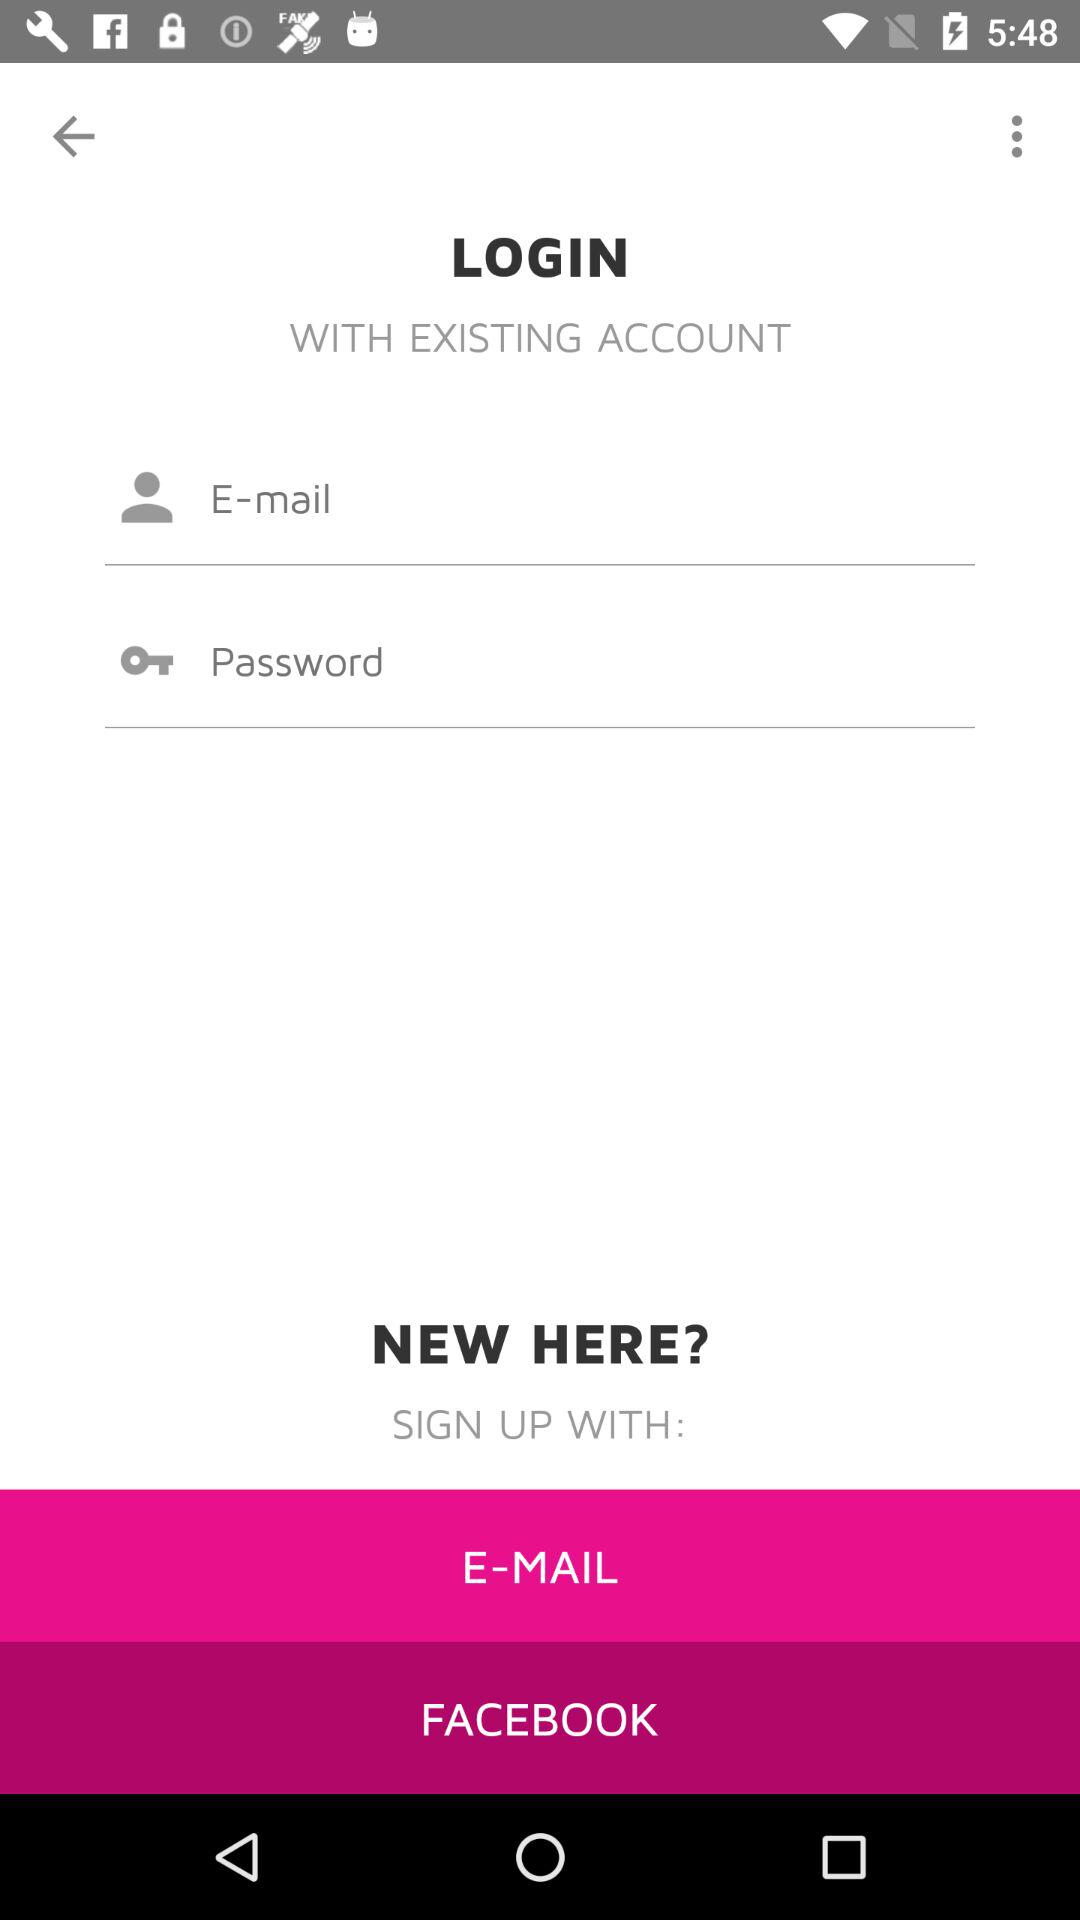How many text inputs are there for logging in?
Answer the question using a single word or phrase. 2 